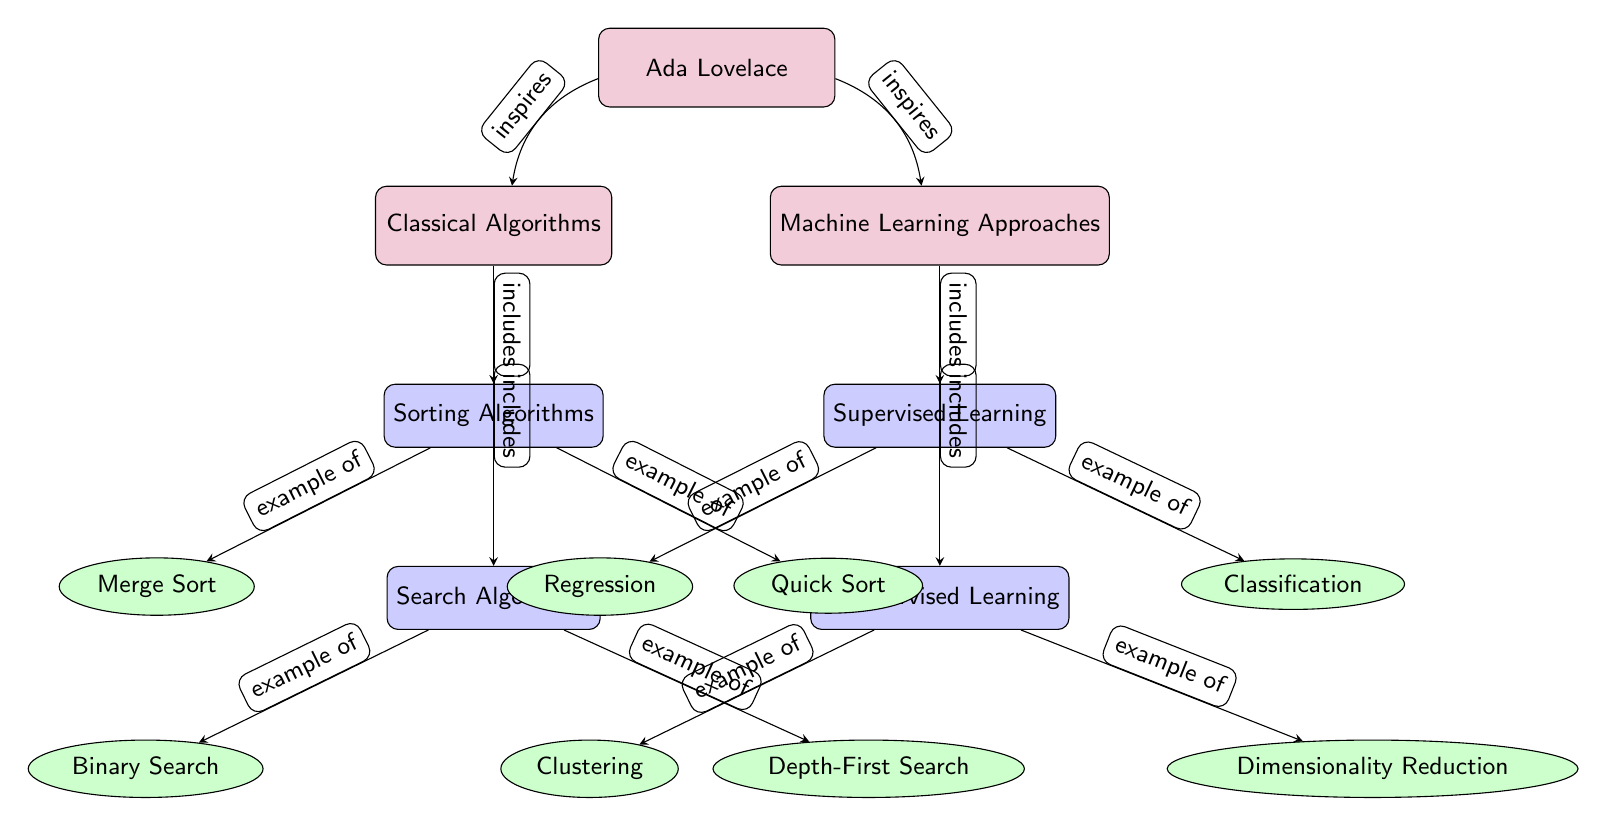What are the two main categories in the diagram? The diagram distinguishes between two main categories: Classical Algorithms and Machine Learning Approaches. These categories are the primary nodes at the top level of the structure.
Answer: Classical Algorithms, Machine Learning Approaches How many subcategories does Classical Algorithms have? By examining the diagram, Classical Algorithms include two subcategories: Sorting Algorithms and Search Algorithms, making a total of two.
Answer: 2 What type of learning falls under Machine Learning? Under Machine Learning Approaches, there are two types of learning illustrated: Supervised Learning and Unsupervised Learning, indicating that both fall under this category.
Answer: Supervised Learning, Unsupervised Learning Which algorithm is classified as an example of Unsupervised Learning? The diagram shows Clustering as an example of Unsupervised Learning, located under the Unsupervised Learning category in the structure.
Answer: Clustering How does Ada Lovelace relate to both Classical Algorithms and Machine Learning? Ada Lovelace, represented at the top of the diagram, inspires both Classical Algorithms and Machine Learning Approaches, indicated by the connecting edges that point to these categories. This illustrates her influence on both areas.
Answer: Inspires What is the relationship between Sorting Algorithms and Merge Sort? The diagram illustrates that Merge Sort is an example of Sorting Algorithms, as indicated by the directed edge connecting these two nodes.
Answer: Example of How many leaf nodes are associated with Machine Learning Approaches? There are four leaf nodes connected to Machine Learning Approaches, including Regression, Classification, Clustering, and Dimensionality Reduction, making up the total count linked to this main category.
Answer: 4 Name one example of a Search Algorithm from the diagram. According to the diagram, one example of a Search Algorithm is Depth-First Search, which is listed under the Search Algorithms subcategory.
Answer: Depth-First Search Which classical algorithm involves sorting? Merge Sort is an example of a classical algorithm that involves sorting, explicitly mentioned as a leaf node connected to Sorting Algorithms.
Answer: Merge Sort 